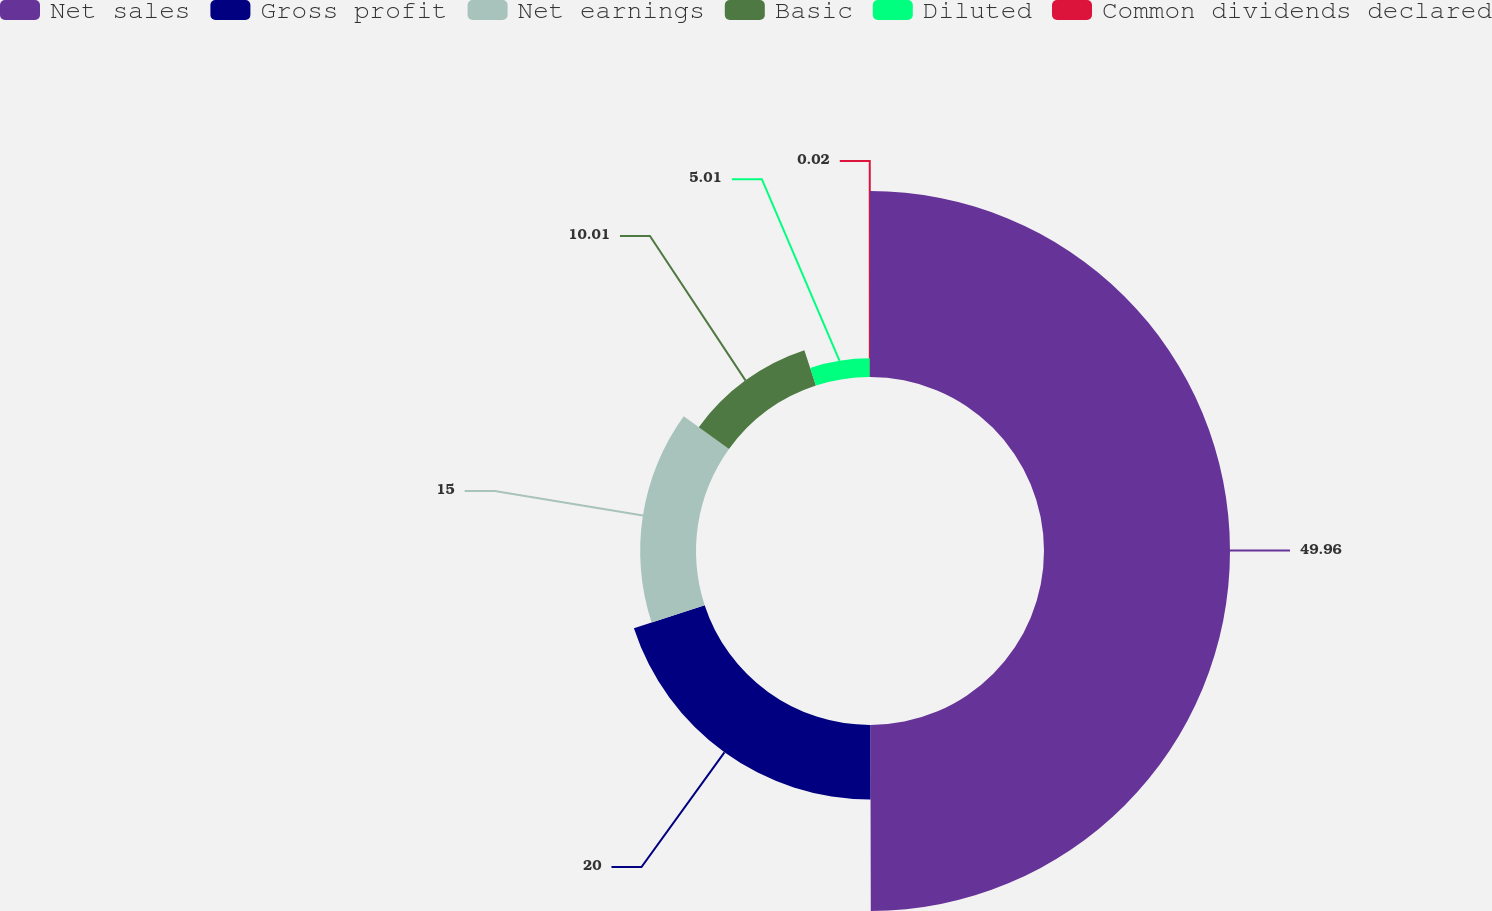<chart> <loc_0><loc_0><loc_500><loc_500><pie_chart><fcel>Net sales<fcel>Gross profit<fcel>Net earnings<fcel>Basic<fcel>Diluted<fcel>Common dividends declared<nl><fcel>49.97%<fcel>20.0%<fcel>15.0%<fcel>10.01%<fcel>5.01%<fcel>0.02%<nl></chart> 